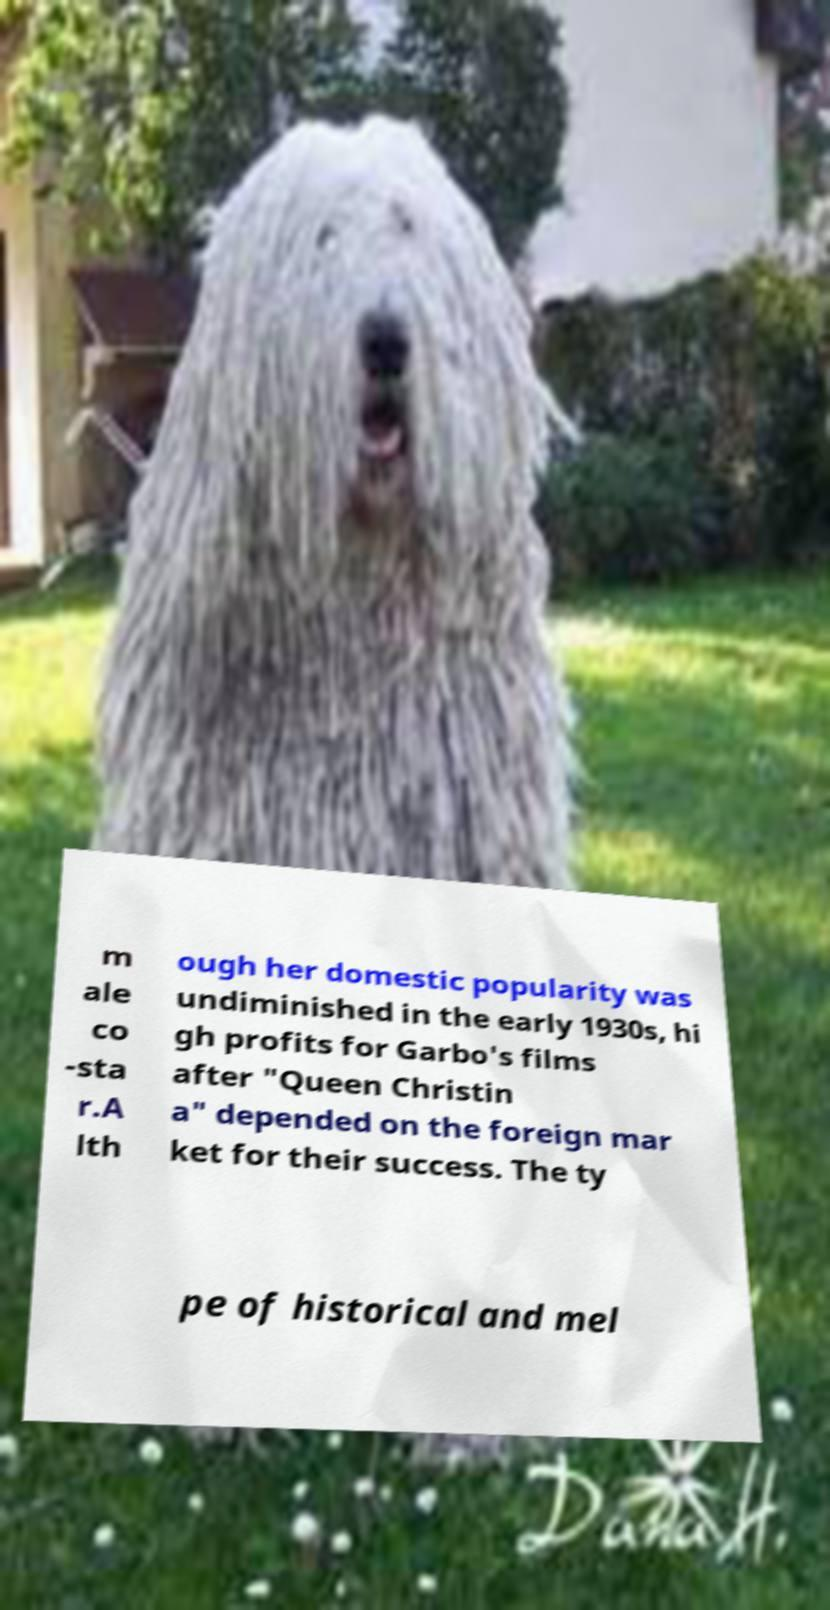Please read and relay the text visible in this image. What does it say? m ale co -sta r.A lth ough her domestic popularity was undiminished in the early 1930s, hi gh profits for Garbo's films after "Queen Christin a" depended on the foreign mar ket for their success. The ty pe of historical and mel 